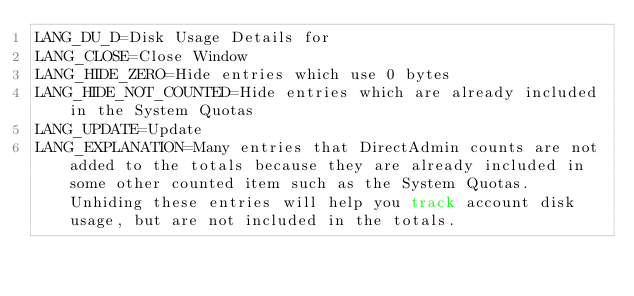Convert code to text. <code><loc_0><loc_0><loc_500><loc_500><_HTML_>LANG_DU_D=Disk Usage Details for
LANG_CLOSE=Close Window
LANG_HIDE_ZERO=Hide entries which use 0 bytes
LANG_HIDE_NOT_COUNTED=Hide entries which are already included in the System Quotas
LANG_UPDATE=Update
LANG_EXPLANATION=Many entries that DirectAdmin counts are not added to the totals because they are already included in some other counted item such as the System Quotas. Unhiding these entries will help you track account disk usage, but are not included in the totals.
</code> 